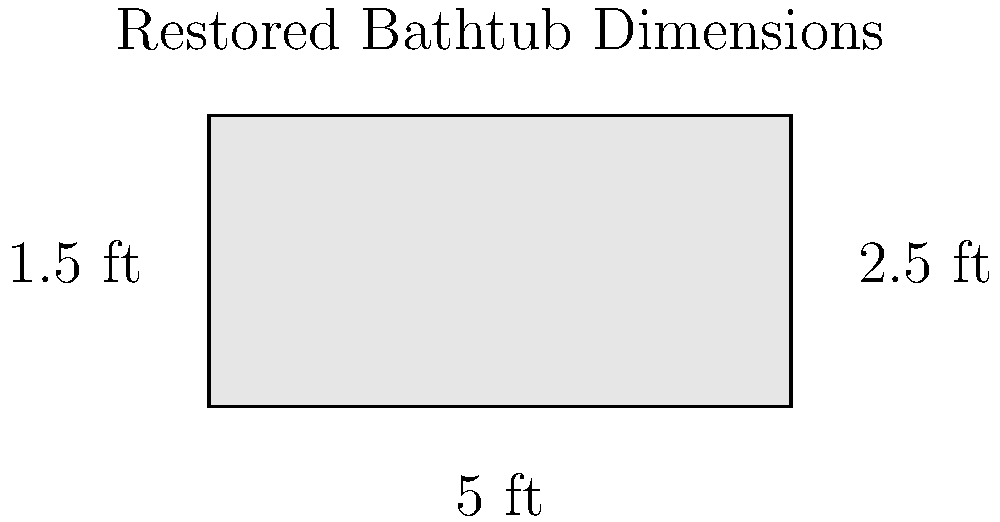After restoring your old bathtub in Hampton Bays, you want to determine its water capacity. The bathtub measures 5 feet long, 2.5 feet wide, and 1.5 feet deep. Calculate the volume of water it can hold in gallons, given that 1 cubic foot is approximately 7.48 gallons. Round your answer to the nearest whole gallon. To find the volume of water the bathtub can hold, we'll follow these steps:

1) Calculate the volume of the bathtub in cubic feet:
   Volume = length × width × depth
   $V = 5 \text{ ft} \times 2.5 \text{ ft} \times 1.5 \text{ ft} = 18.75 \text{ ft}^3$

2) Convert cubic feet to gallons:
   $18.75 \text{ ft}^3 \times 7.48 \text{ gallons/ft}^3 = 140.25 \text{ gallons}$

3) Round to the nearest whole gallon:
   140.25 rounds to 140 gallons

Therefore, the restored bathtub can hold approximately 140 gallons of water.
Answer: 140 gallons 